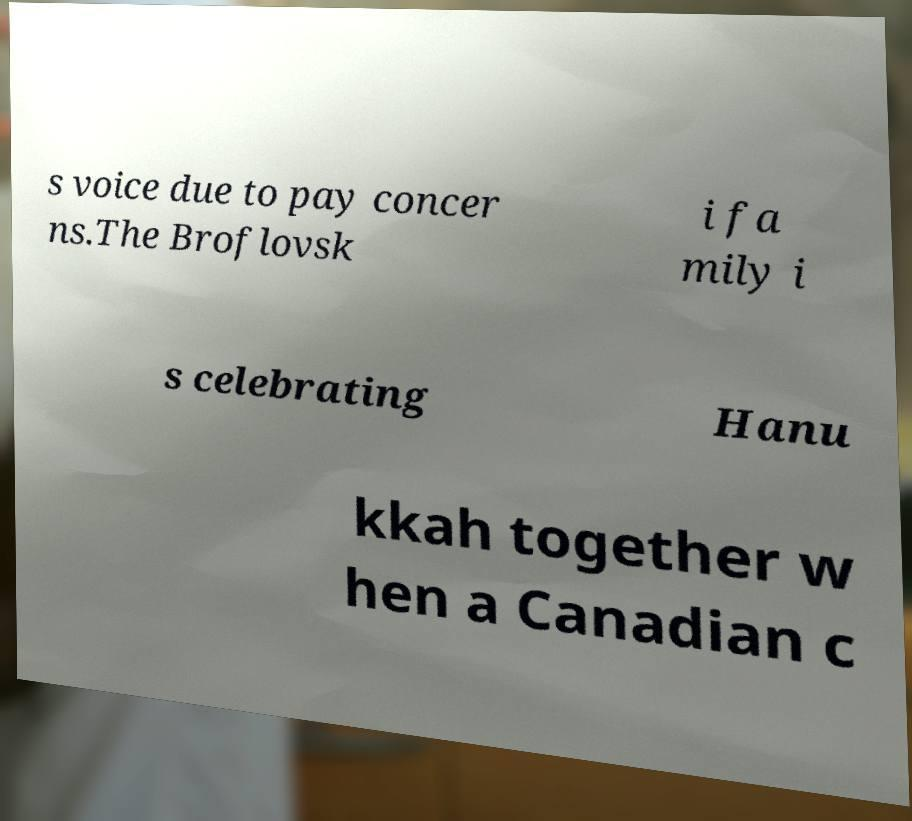There's text embedded in this image that I need extracted. Can you transcribe it verbatim? s voice due to pay concer ns.The Broflovsk i fa mily i s celebrating Hanu kkah together w hen a Canadian c 